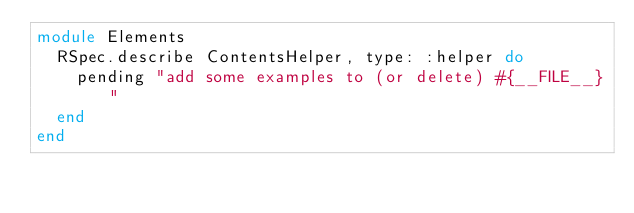Convert code to text. <code><loc_0><loc_0><loc_500><loc_500><_Ruby_>module Elements
  RSpec.describe ContentsHelper, type: :helper do
    pending "add some examples to (or delete) #{__FILE__}"
  end
end
</code> 